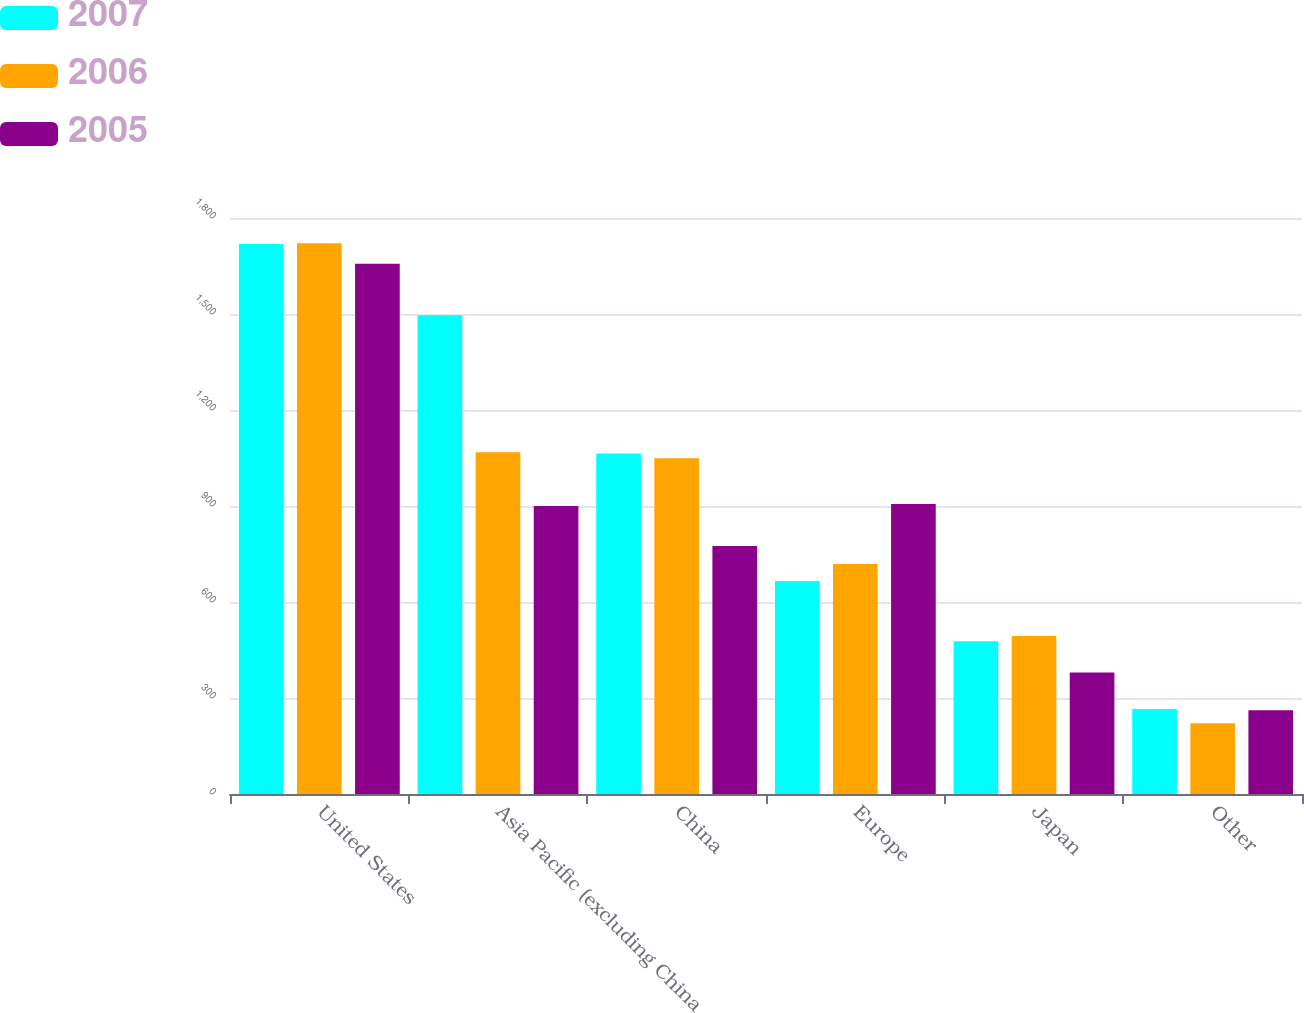Convert chart to OTSL. <chart><loc_0><loc_0><loc_500><loc_500><stacked_bar_chart><ecel><fcel>United States<fcel>Asia Pacific (excluding China<fcel>China<fcel>Europe<fcel>Japan<fcel>Other<nl><fcel>2007<fcel>1719<fcel>1496<fcel>1064<fcel>666<fcel>477<fcel>266<nl><fcel>2006<fcel>1721<fcel>1068<fcel>1049<fcel>719<fcel>494<fcel>221<nl><fcel>2005<fcel>1657<fcel>900<fcel>775<fcel>906<fcel>380<fcel>262<nl></chart> 